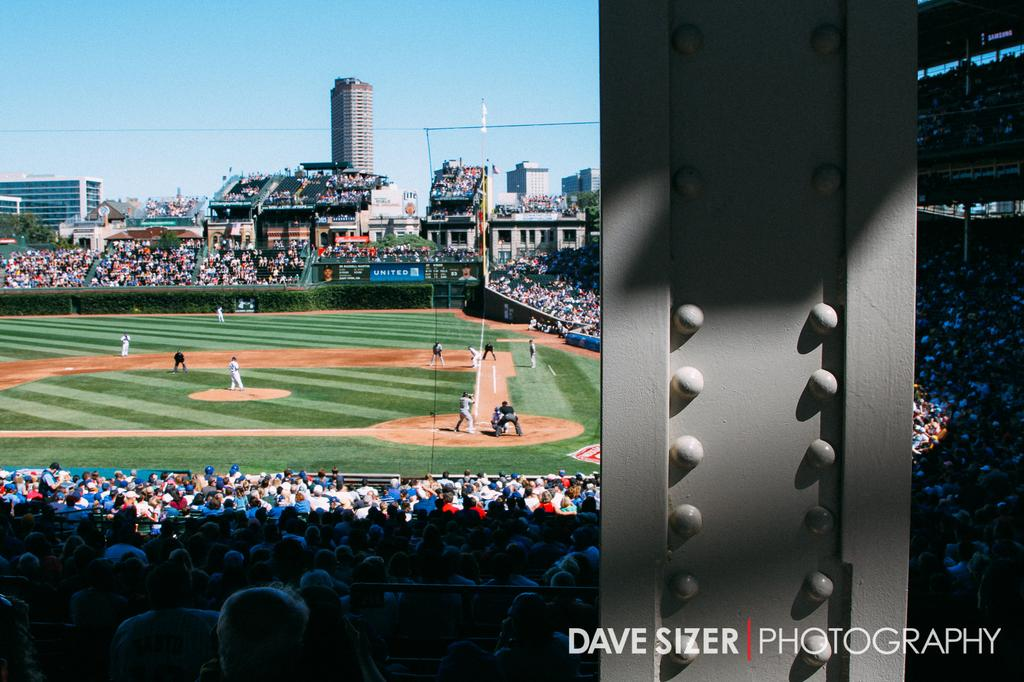What type of sports ground is visible in the image? There is a baseball ground in the image. What are the players doing on the baseball ground? The players are present on the baseball ground and are playing a game. Can you describe the people watching the game? There is an audience in the image, and they are sitting on chairs. Is there any text visible in the image? Yes, there is text in the bottom right corner of the image. How many trains can be seen passing by the baseball ground in the image? There are no trains visible in the image; it features a baseball ground with players and an audience. What type of swing is being used by the players in the image? The image does not show any specific type of swing being used by the players; it only shows them playing a game. 